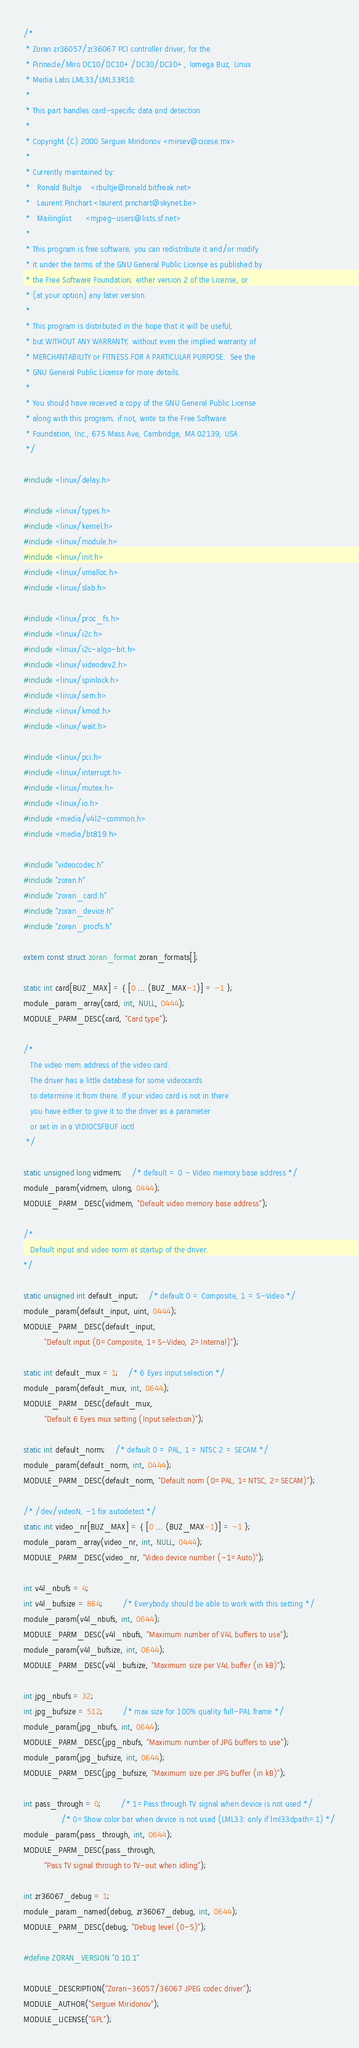Convert code to text. <code><loc_0><loc_0><loc_500><loc_500><_C_>/*
 * Zoran zr36057/zr36067 PCI controller driver, for the
 * Pinnacle/Miro DC10/DC10+/DC30/DC30+, Iomega Buz, Linux
 * Media Labs LML33/LML33R10.
 *
 * This part handles card-specific data and detection
 *
 * Copyright (C) 2000 Serguei Miridonov <mirsev@cicese.mx>
 *
 * Currently maintained by:
 *   Ronald Bultje    <rbultje@ronald.bitfreak.net>
 *   Laurent Pinchart <laurent.pinchart@skynet.be>
 *   Mailinglist      <mjpeg-users@lists.sf.net>
 *
 * This program is free software; you can redistribute it and/or modify
 * it under the terms of the GNU General Public License as published by
 * the Free Software Foundation; either version 2 of the License, or
 * (at your option) any later version.
 *
 * This program is distributed in the hope that it will be useful,
 * but WITHOUT ANY WARRANTY; without even the implied warranty of
 * MERCHANTABILITY or FITNESS FOR A PARTICULAR PURPOSE.  See the
 * GNU General Public License for more details.
 *
 * You should have received a copy of the GNU General Public License
 * along with this program; if not, write to the Free Software
 * Foundation, Inc., 675 Mass Ave, Cambridge, MA 02139, USA.
 */

#include <linux/delay.h>

#include <linux/types.h>
#include <linux/kernel.h>
#include <linux/module.h>
#include <linux/init.h>
#include <linux/vmalloc.h>
#include <linux/slab.h>

#include <linux/proc_fs.h>
#include <linux/i2c.h>
#include <linux/i2c-algo-bit.h>
#include <linux/videodev2.h>
#include <linux/spinlock.h>
#include <linux/sem.h>
#include <linux/kmod.h>
#include <linux/wait.h>

#include <linux/pci.h>
#include <linux/interrupt.h>
#include <linux/mutex.h>
#include <linux/io.h>
#include <media/v4l2-common.h>
#include <media/bt819.h>

#include "videocodec.h"
#include "zoran.h"
#include "zoran_card.h"
#include "zoran_device.h"
#include "zoran_procfs.h"

extern const struct zoran_format zoran_formats[];

static int card[BUZ_MAX] = { [0 ... (BUZ_MAX-1)] = -1 };
module_param_array(card, int, NULL, 0444);
MODULE_PARM_DESC(card, "Card type");

/*
   The video mem address of the video card.
   The driver has a little database for some videocards
   to determine it from there. If your video card is not in there
   you have either to give it to the driver as a parameter
   or set in in a VIDIOCSFBUF ioctl
 */

static unsigned long vidmem;	/* default = 0 - Video memory base address */
module_param(vidmem, ulong, 0444);
MODULE_PARM_DESC(vidmem, "Default video memory base address");

/*
   Default input and video norm at startup of the driver.
*/

static unsigned int default_input;	/* default 0 = Composite, 1 = S-Video */
module_param(default_input, uint, 0444);
MODULE_PARM_DESC(default_input,
		 "Default input (0=Composite, 1=S-Video, 2=Internal)");

static int default_mux = 1;	/* 6 Eyes input selection */
module_param(default_mux, int, 0644);
MODULE_PARM_DESC(default_mux,
		 "Default 6 Eyes mux setting (Input selection)");

static int default_norm;	/* default 0 = PAL, 1 = NTSC 2 = SECAM */
module_param(default_norm, int, 0444);
MODULE_PARM_DESC(default_norm, "Default norm (0=PAL, 1=NTSC, 2=SECAM)");

/* /dev/videoN, -1 for autodetect */
static int video_nr[BUZ_MAX] = { [0 ... (BUZ_MAX-1)] = -1 };
module_param_array(video_nr, int, NULL, 0444);
MODULE_PARM_DESC(video_nr, "Video device number (-1=Auto)");

int v4l_nbufs = 4;
int v4l_bufsize = 864;		/* Everybody should be able to work with this setting */
module_param(v4l_nbufs, int, 0644);
MODULE_PARM_DESC(v4l_nbufs, "Maximum number of V4L buffers to use");
module_param(v4l_bufsize, int, 0644);
MODULE_PARM_DESC(v4l_bufsize, "Maximum size per V4L buffer (in kB)");

int jpg_nbufs = 32;
int jpg_bufsize = 512;		/* max size for 100% quality full-PAL frame */
module_param(jpg_nbufs, int, 0644);
MODULE_PARM_DESC(jpg_nbufs, "Maximum number of JPG buffers to use");
module_param(jpg_bufsize, int, 0644);
MODULE_PARM_DESC(jpg_bufsize, "Maximum size per JPG buffer (in kB)");

int pass_through = 0;		/* 1=Pass through TV signal when device is not used */
				/* 0=Show color bar when device is not used (LML33: only if lml33dpath=1) */
module_param(pass_through, int, 0644);
MODULE_PARM_DESC(pass_through,
		 "Pass TV signal through to TV-out when idling");

int zr36067_debug = 1;
module_param_named(debug, zr36067_debug, int, 0644);
MODULE_PARM_DESC(debug, "Debug level (0-5)");

#define ZORAN_VERSION "0.10.1"

MODULE_DESCRIPTION("Zoran-36057/36067 JPEG codec driver");
MODULE_AUTHOR("Serguei Miridonov");
MODULE_LICENSE("GPL");</code> 